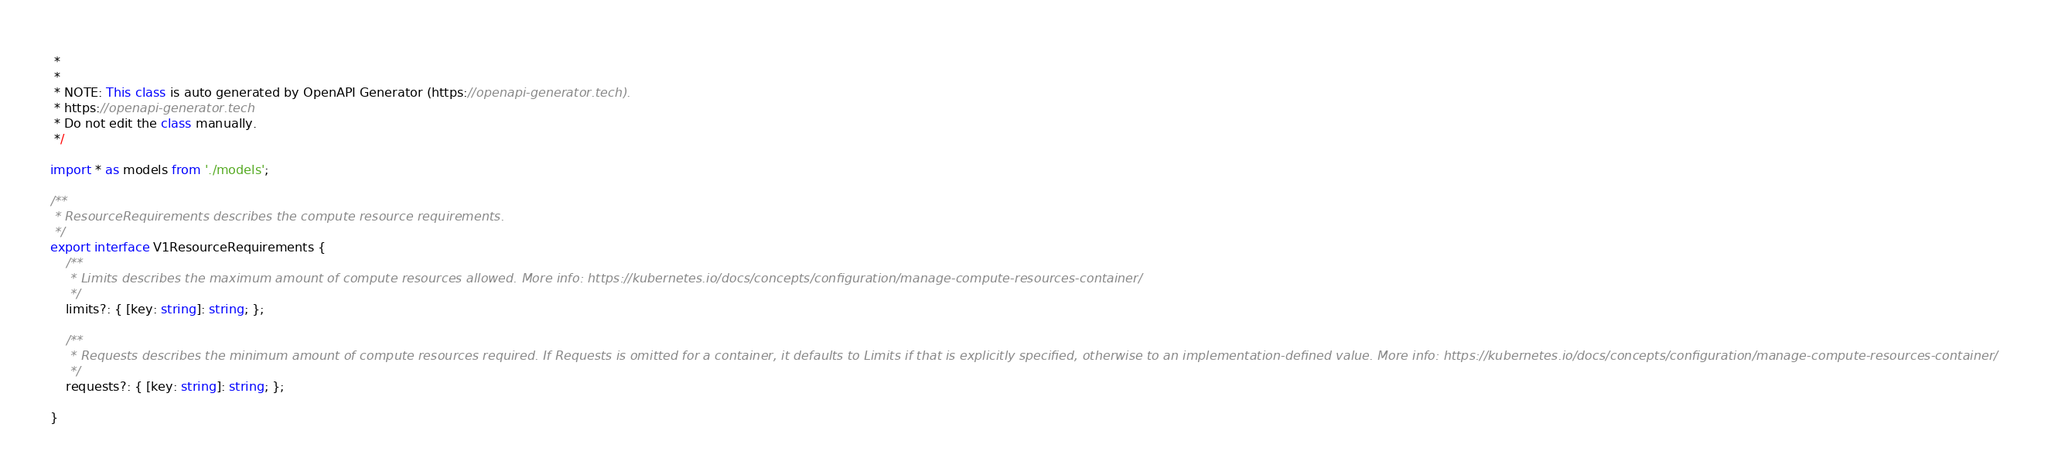<code> <loc_0><loc_0><loc_500><loc_500><_TypeScript_> * 
 *
 * NOTE: This class is auto generated by OpenAPI Generator (https://openapi-generator.tech).
 * https://openapi-generator.tech
 * Do not edit the class manually.
 */

import * as models from './models';

/**
 * ResourceRequirements describes the compute resource requirements.
 */
export interface V1ResourceRequirements {
    /**
     * Limits describes the maximum amount of compute resources allowed. More info: https://kubernetes.io/docs/concepts/configuration/manage-compute-resources-container/
     */
    limits?: { [key: string]: string; };

    /**
     * Requests describes the minimum amount of compute resources required. If Requests is omitted for a container, it defaults to Limits if that is explicitly specified, otherwise to an implementation-defined value. More info: https://kubernetes.io/docs/concepts/configuration/manage-compute-resources-container/
     */
    requests?: { [key: string]: string; };

}
</code> 